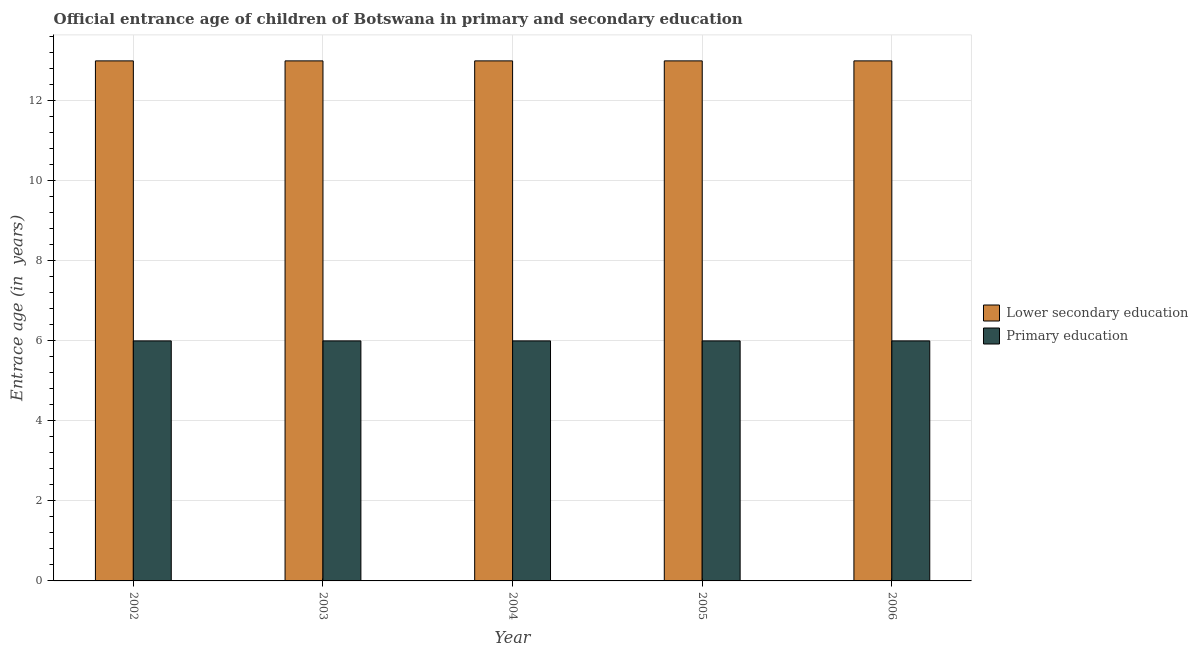How many different coloured bars are there?
Provide a succinct answer. 2. Are the number of bars per tick equal to the number of legend labels?
Offer a terse response. Yes. Are the number of bars on each tick of the X-axis equal?
Ensure brevity in your answer.  Yes. How many bars are there on the 2nd tick from the left?
Make the answer very short. 2. How many bars are there on the 4th tick from the right?
Ensure brevity in your answer.  2. Across all years, what is the maximum entrance age of chiildren in primary education?
Keep it short and to the point. 6. In which year was the entrance age of chiildren in primary education maximum?
Your response must be concise. 2002. In which year was the entrance age of chiildren in primary education minimum?
Give a very brief answer. 2002. What is the total entrance age of children in lower secondary education in the graph?
Keep it short and to the point. 65. What is the average entrance age of children in lower secondary education per year?
Give a very brief answer. 13. In the year 2003, what is the difference between the entrance age of children in lower secondary education and entrance age of chiildren in primary education?
Your response must be concise. 0. Is the difference between the entrance age of chiildren in primary education in 2004 and 2006 greater than the difference between the entrance age of children in lower secondary education in 2004 and 2006?
Provide a short and direct response. No. In how many years, is the entrance age of children in lower secondary education greater than the average entrance age of children in lower secondary education taken over all years?
Keep it short and to the point. 0. What does the 1st bar from the right in 2003 represents?
Your answer should be very brief. Primary education. How many bars are there?
Your answer should be compact. 10. Are all the bars in the graph horizontal?
Make the answer very short. No. Are the values on the major ticks of Y-axis written in scientific E-notation?
Ensure brevity in your answer.  No. Does the graph contain any zero values?
Keep it short and to the point. No. Does the graph contain grids?
Offer a very short reply. Yes. What is the title of the graph?
Provide a succinct answer. Official entrance age of children of Botswana in primary and secondary education. Does "Passenger Transport Items" appear as one of the legend labels in the graph?
Offer a very short reply. No. What is the label or title of the X-axis?
Keep it short and to the point. Year. What is the label or title of the Y-axis?
Give a very brief answer. Entrace age (in  years). What is the Entrace age (in  years) of Primary education in 2003?
Give a very brief answer. 6. What is the Entrace age (in  years) in Lower secondary education in 2004?
Keep it short and to the point. 13. What is the Entrace age (in  years) of Lower secondary education in 2005?
Make the answer very short. 13. What is the Entrace age (in  years) in Lower secondary education in 2006?
Make the answer very short. 13. What is the Entrace age (in  years) of Primary education in 2006?
Make the answer very short. 6. Across all years, what is the maximum Entrace age (in  years) in Lower secondary education?
Your answer should be very brief. 13. What is the difference between the Entrace age (in  years) of Primary education in 2002 and that in 2003?
Ensure brevity in your answer.  0. What is the difference between the Entrace age (in  years) in Primary education in 2002 and that in 2004?
Provide a short and direct response. 0. What is the difference between the Entrace age (in  years) in Primary education in 2002 and that in 2005?
Your response must be concise. 0. What is the difference between the Entrace age (in  years) of Primary education in 2002 and that in 2006?
Ensure brevity in your answer.  0. What is the difference between the Entrace age (in  years) in Primary education in 2003 and that in 2004?
Your answer should be compact. 0. What is the difference between the Entrace age (in  years) of Lower secondary education in 2003 and that in 2006?
Your answer should be very brief. 0. What is the difference between the Entrace age (in  years) in Lower secondary education in 2004 and that in 2005?
Your answer should be very brief. 0. What is the difference between the Entrace age (in  years) of Lower secondary education in 2004 and that in 2006?
Keep it short and to the point. 0. What is the difference between the Entrace age (in  years) of Lower secondary education in 2005 and that in 2006?
Make the answer very short. 0. What is the difference between the Entrace age (in  years) of Lower secondary education in 2002 and the Entrace age (in  years) of Primary education in 2003?
Offer a terse response. 7. What is the difference between the Entrace age (in  years) of Lower secondary education in 2002 and the Entrace age (in  years) of Primary education in 2004?
Offer a terse response. 7. What is the difference between the Entrace age (in  years) of Lower secondary education in 2002 and the Entrace age (in  years) of Primary education in 2005?
Offer a very short reply. 7. What is the difference between the Entrace age (in  years) in Lower secondary education in 2002 and the Entrace age (in  years) in Primary education in 2006?
Make the answer very short. 7. What is the difference between the Entrace age (in  years) of Lower secondary education in 2003 and the Entrace age (in  years) of Primary education in 2004?
Offer a terse response. 7. What is the difference between the Entrace age (in  years) in Lower secondary education in 2004 and the Entrace age (in  years) in Primary education in 2005?
Make the answer very short. 7. What is the difference between the Entrace age (in  years) of Lower secondary education in 2005 and the Entrace age (in  years) of Primary education in 2006?
Ensure brevity in your answer.  7. What is the average Entrace age (in  years) of Primary education per year?
Offer a very short reply. 6. In the year 2003, what is the difference between the Entrace age (in  years) in Lower secondary education and Entrace age (in  years) in Primary education?
Keep it short and to the point. 7. In the year 2005, what is the difference between the Entrace age (in  years) of Lower secondary education and Entrace age (in  years) of Primary education?
Keep it short and to the point. 7. In the year 2006, what is the difference between the Entrace age (in  years) in Lower secondary education and Entrace age (in  years) in Primary education?
Your answer should be compact. 7. What is the ratio of the Entrace age (in  years) in Lower secondary education in 2002 to that in 2003?
Your answer should be very brief. 1. What is the ratio of the Entrace age (in  years) of Primary education in 2002 to that in 2003?
Keep it short and to the point. 1. What is the ratio of the Entrace age (in  years) in Lower secondary education in 2002 to that in 2004?
Keep it short and to the point. 1. What is the ratio of the Entrace age (in  years) of Lower secondary education in 2002 to that in 2005?
Keep it short and to the point. 1. What is the ratio of the Entrace age (in  years) in Lower secondary education in 2003 to that in 2004?
Ensure brevity in your answer.  1. What is the ratio of the Entrace age (in  years) in Primary education in 2003 to that in 2004?
Provide a short and direct response. 1. What is the ratio of the Entrace age (in  years) in Lower secondary education in 2003 to that in 2005?
Keep it short and to the point. 1. What is the ratio of the Entrace age (in  years) in Primary education in 2003 to that in 2005?
Offer a very short reply. 1. What is the ratio of the Entrace age (in  years) of Primary education in 2004 to that in 2005?
Give a very brief answer. 1. What is the ratio of the Entrace age (in  years) in Lower secondary education in 2004 to that in 2006?
Provide a succinct answer. 1. What is the ratio of the Entrace age (in  years) of Primary education in 2005 to that in 2006?
Your response must be concise. 1. What is the difference between the highest and the second highest Entrace age (in  years) of Primary education?
Your response must be concise. 0. What is the difference between the highest and the lowest Entrace age (in  years) of Primary education?
Offer a very short reply. 0. 